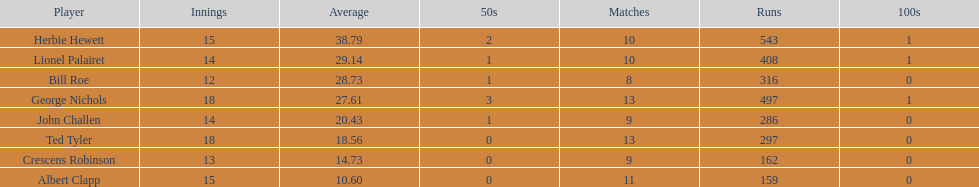What were the number of innings albert clapp had? 15. 